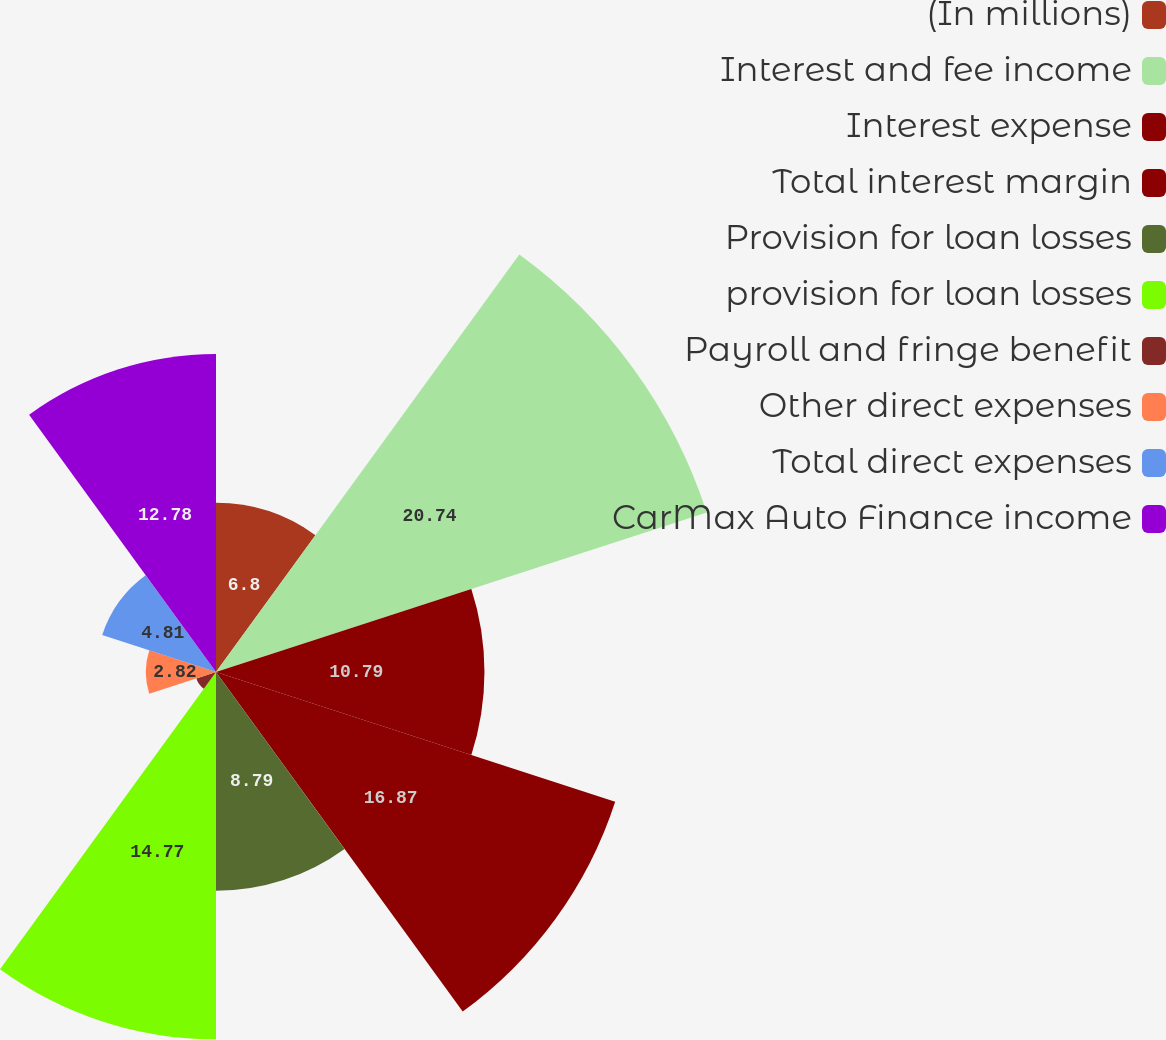<chart> <loc_0><loc_0><loc_500><loc_500><pie_chart><fcel>(In millions)<fcel>Interest and fee income<fcel>Interest expense<fcel>Total interest margin<fcel>Provision for loan losses<fcel>provision for loan losses<fcel>Payroll and fringe benefit<fcel>Other direct expenses<fcel>Total direct expenses<fcel>CarMax Auto Finance income<nl><fcel>6.8%<fcel>20.74%<fcel>10.79%<fcel>16.87%<fcel>8.79%<fcel>14.77%<fcel>0.83%<fcel>2.82%<fcel>4.81%<fcel>12.78%<nl></chart> 